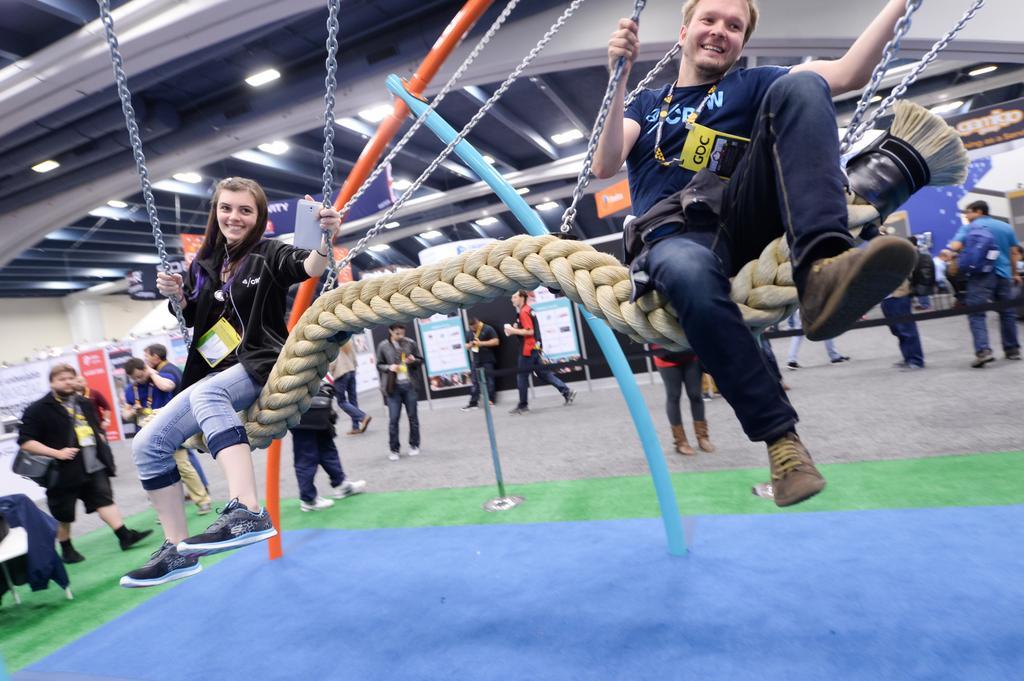How would you summarize this image in a sentence or two? In this image in the front there are persons sitting on cradle and smiling. in the background there are persons standing and walking and there are boards with some text written on it. 